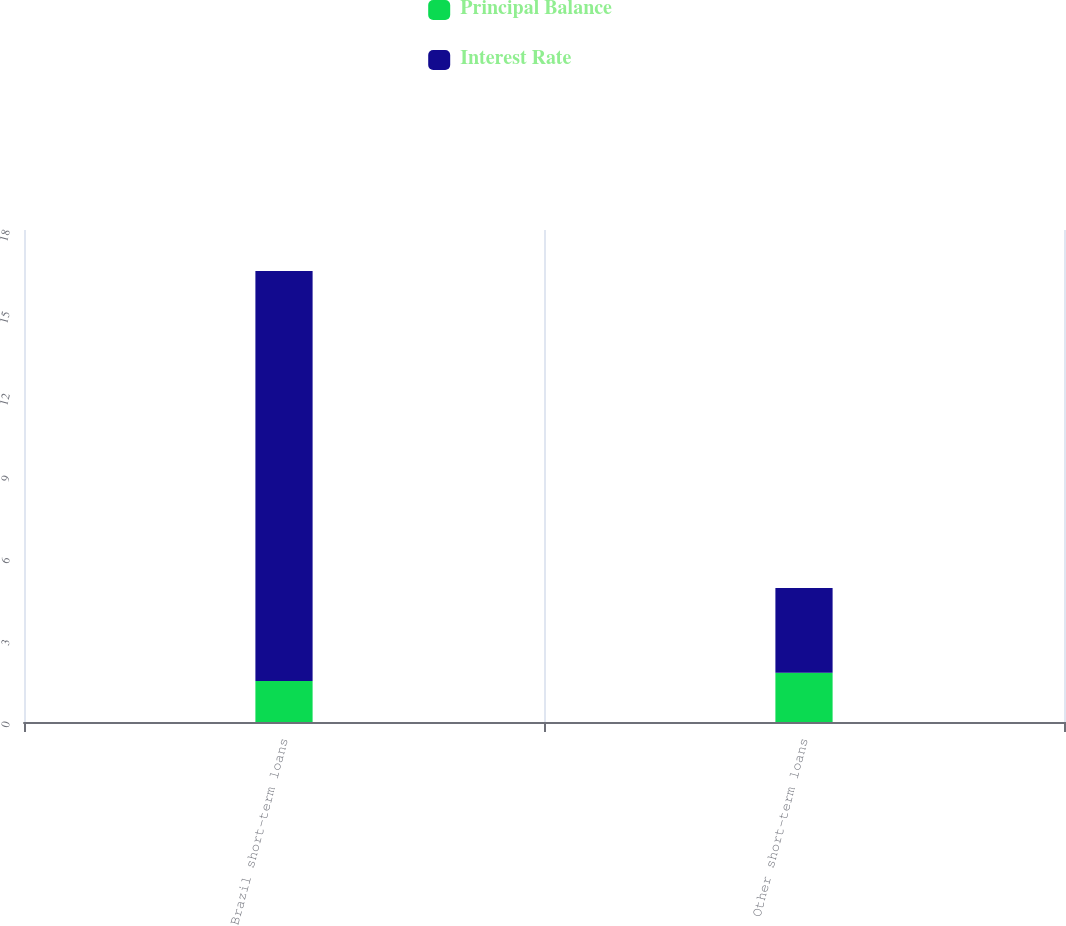<chart> <loc_0><loc_0><loc_500><loc_500><stacked_bar_chart><ecel><fcel>Brazil short-term loans<fcel>Other short-term loans<nl><fcel>Principal Balance<fcel>1.5<fcel>1.8<nl><fcel>Interest Rate<fcel>15<fcel>3.1<nl></chart> 